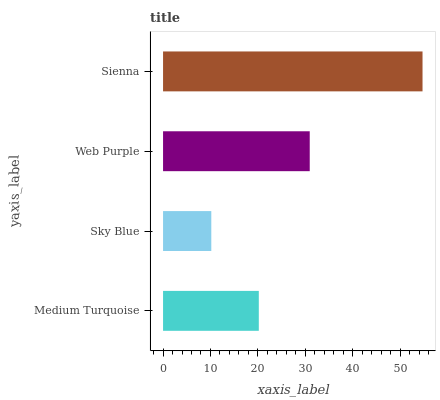Is Sky Blue the minimum?
Answer yes or no. Yes. Is Sienna the maximum?
Answer yes or no. Yes. Is Web Purple the minimum?
Answer yes or no. No. Is Web Purple the maximum?
Answer yes or no. No. Is Web Purple greater than Sky Blue?
Answer yes or no. Yes. Is Sky Blue less than Web Purple?
Answer yes or no. Yes. Is Sky Blue greater than Web Purple?
Answer yes or no. No. Is Web Purple less than Sky Blue?
Answer yes or no. No. Is Web Purple the high median?
Answer yes or no. Yes. Is Medium Turquoise the low median?
Answer yes or no. Yes. Is Medium Turquoise the high median?
Answer yes or no. No. Is Sienna the low median?
Answer yes or no. No. 